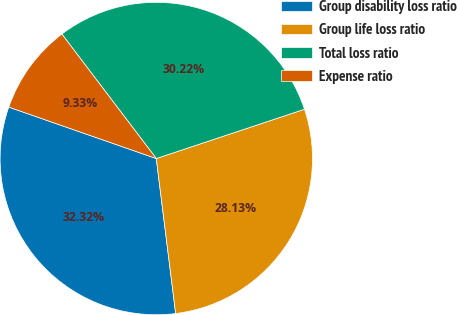Convert chart. <chart><loc_0><loc_0><loc_500><loc_500><pie_chart><fcel>Group disability loss ratio<fcel>Group life loss ratio<fcel>Total loss ratio<fcel>Expense ratio<nl><fcel>32.32%<fcel>28.13%<fcel>30.22%<fcel>9.33%<nl></chart> 